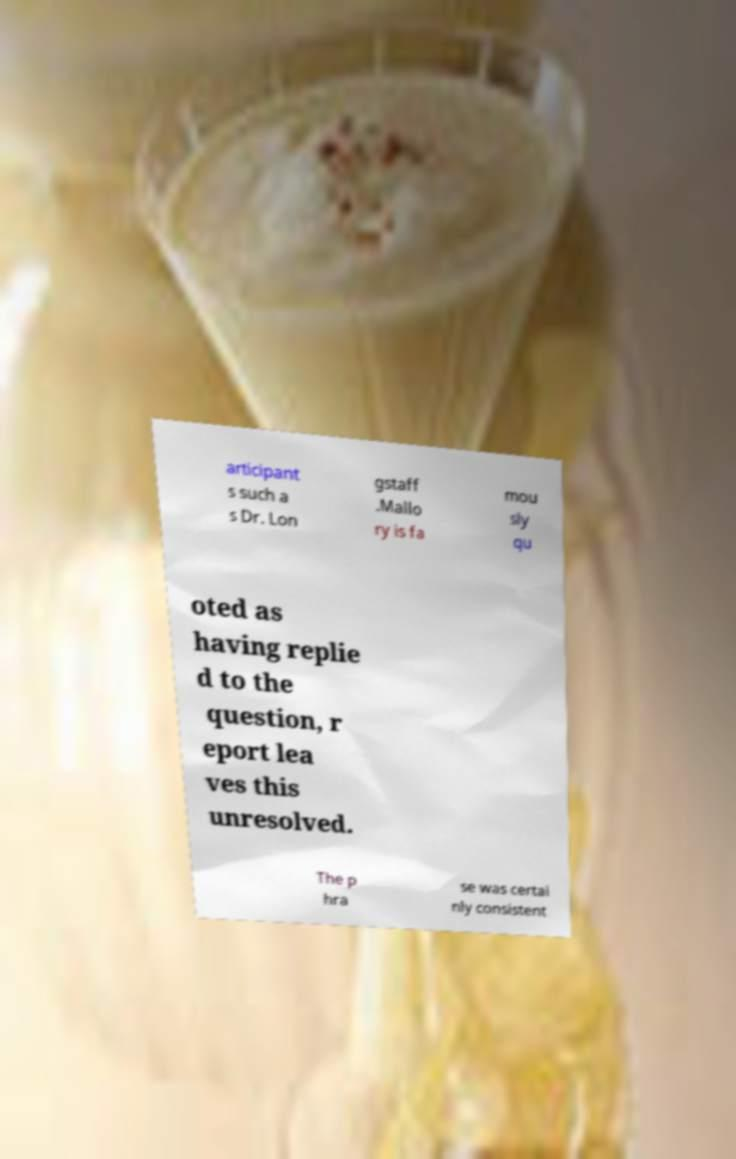Can you read and provide the text displayed in the image?This photo seems to have some interesting text. Can you extract and type it out for me? articipant s such a s Dr. Lon gstaff .Mallo ry is fa mou sly qu oted as having replie d to the question, r eport lea ves this unresolved. The p hra se was certai nly consistent 